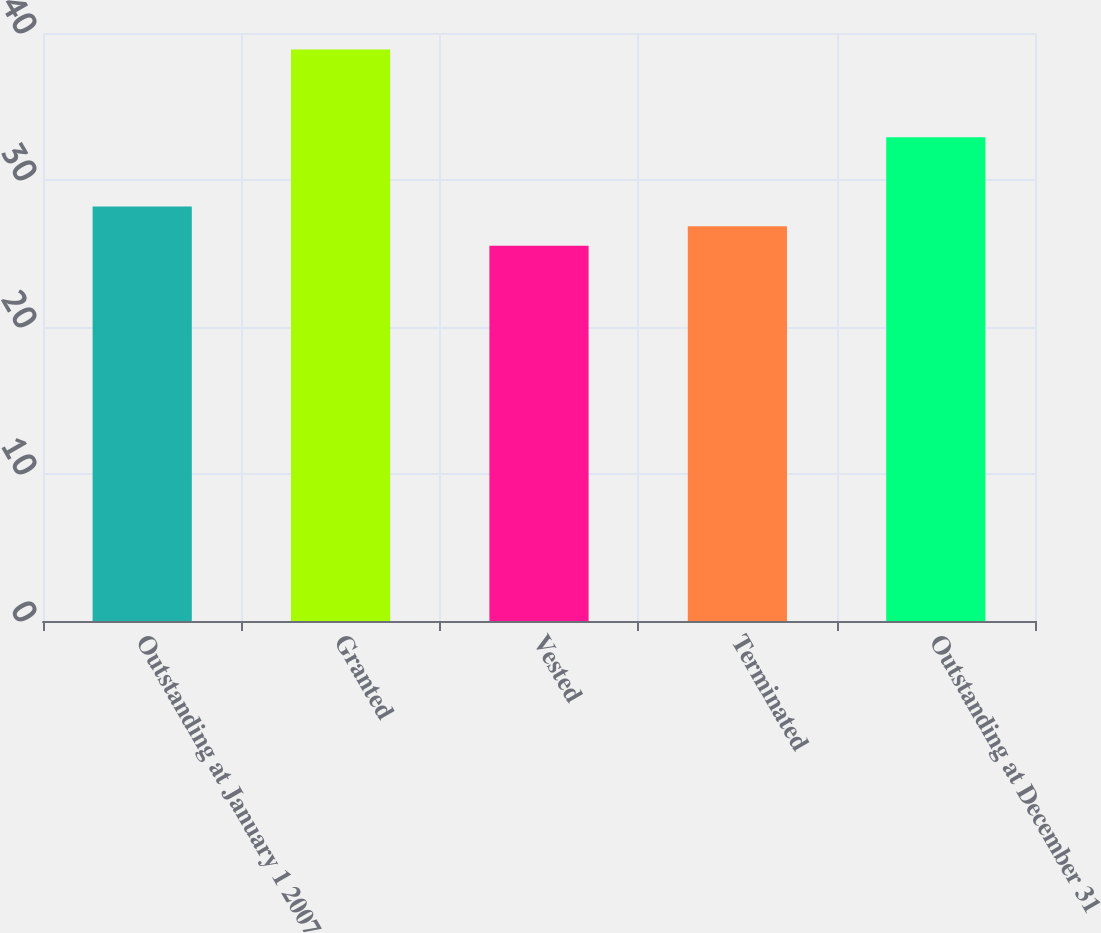Convert chart to OTSL. <chart><loc_0><loc_0><loc_500><loc_500><bar_chart><fcel>Outstanding at January 1 2007<fcel>Granted<fcel>Vested<fcel>Terminated<fcel>Outstanding at December 31<nl><fcel>28.2<fcel>38.87<fcel>25.52<fcel>26.86<fcel>32.91<nl></chart> 